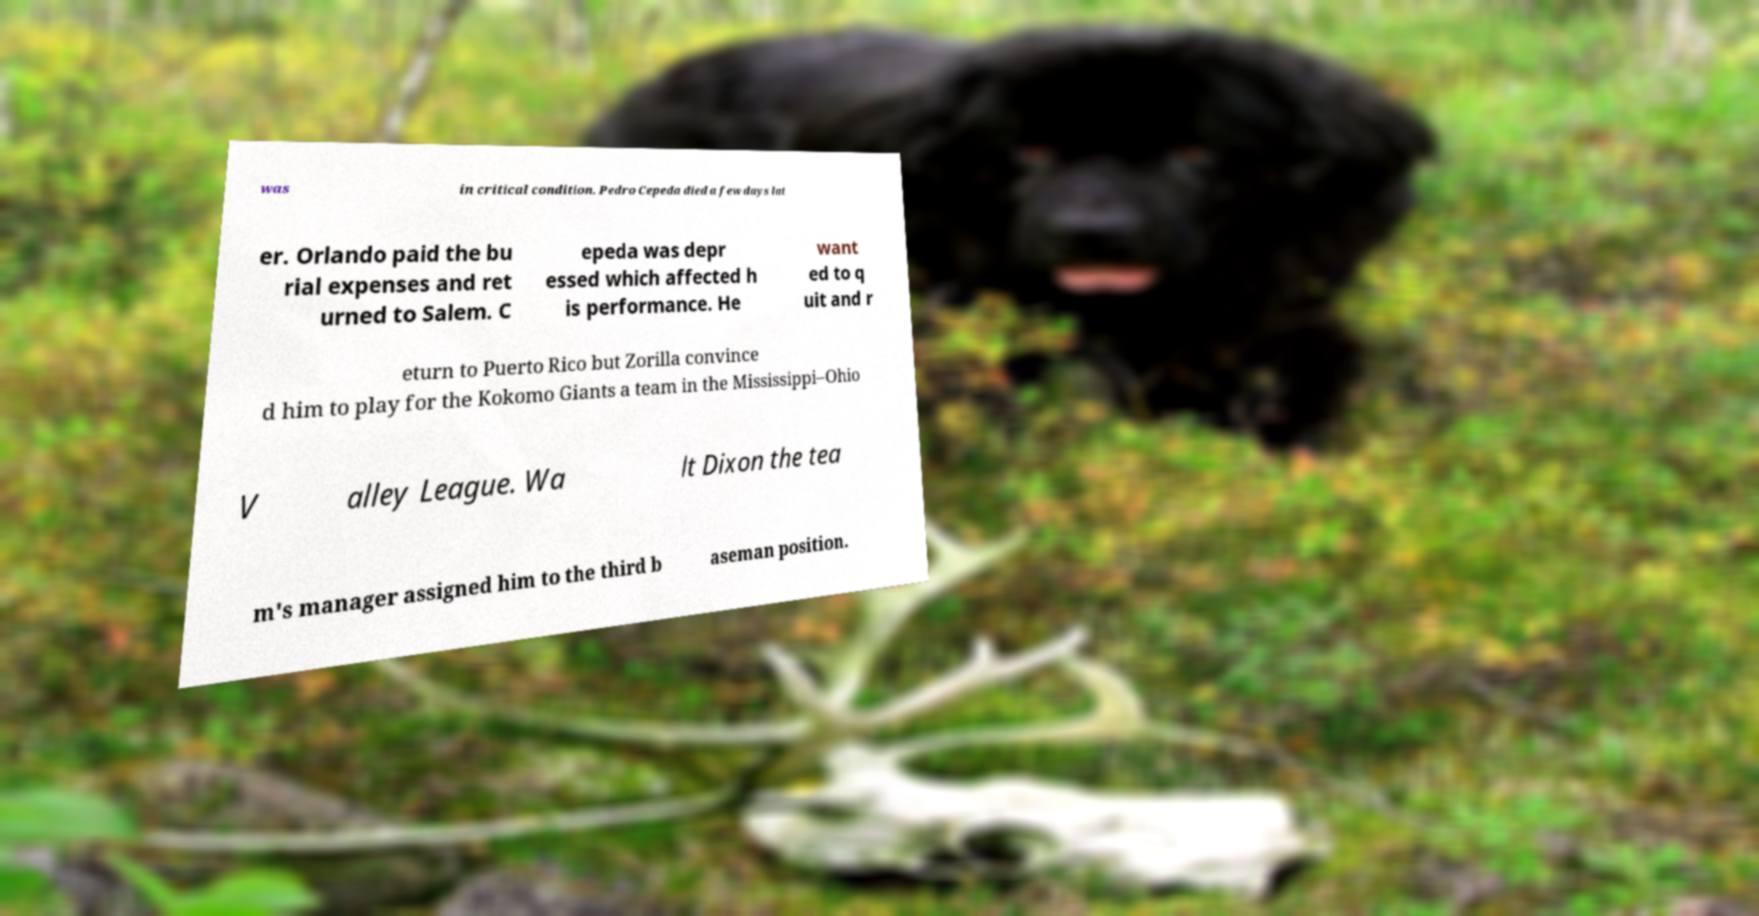Could you extract and type out the text from this image? was in critical condition. Pedro Cepeda died a few days lat er. Orlando paid the bu rial expenses and ret urned to Salem. C epeda was depr essed which affected h is performance. He want ed to q uit and r eturn to Puerto Rico but Zorilla convince d him to play for the Kokomo Giants a team in the Mississippi–Ohio V alley League. Wa lt Dixon the tea m's manager assigned him to the third b aseman position. 